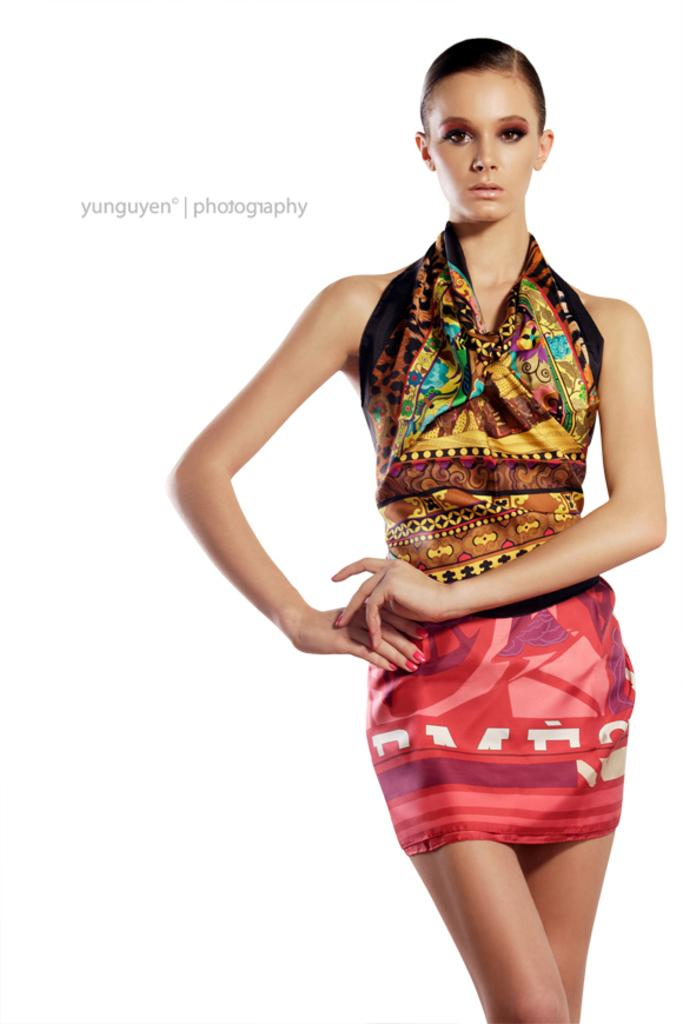Who is present in the image? There is a woman in the image. What color is the background of the image? The background of the image is white in color. Can you see any docks in the image? There is no dock present in the image. What type of ice is the woman holding in the image? There is no ice visible in the image. 